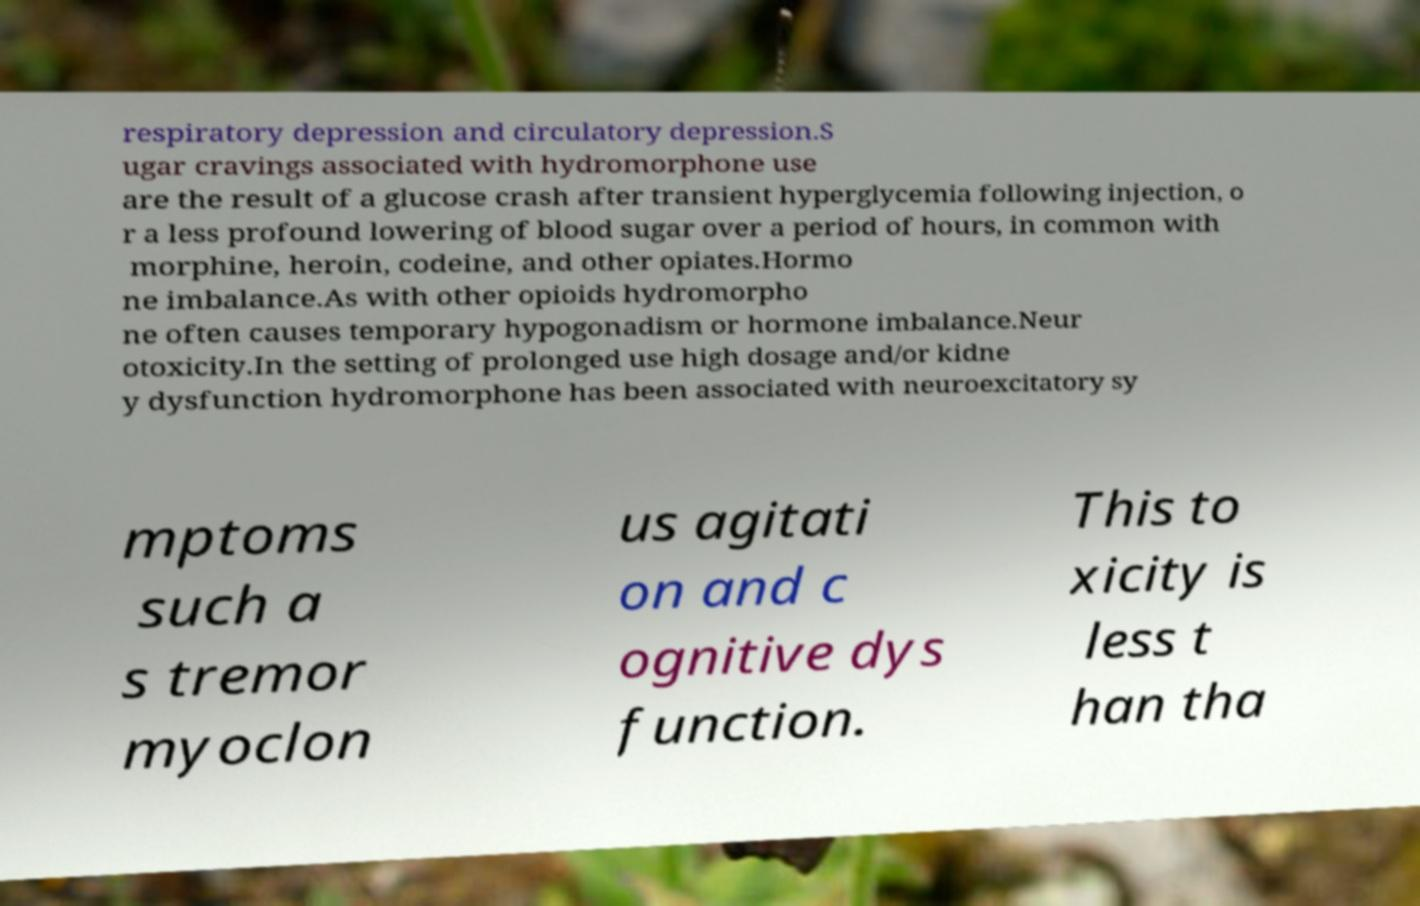Can you accurately transcribe the text from the provided image for me? respiratory depression and circulatory depression.S ugar cravings associated with hydromorphone use are the result of a glucose crash after transient hyperglycemia following injection, o r a less profound lowering of blood sugar over a period of hours, in common with morphine, heroin, codeine, and other opiates.Hormo ne imbalance.As with other opioids hydromorpho ne often causes temporary hypogonadism or hormone imbalance.Neur otoxicity.In the setting of prolonged use high dosage and/or kidne y dysfunction hydromorphone has been associated with neuroexcitatory sy mptoms such a s tremor myoclon us agitati on and c ognitive dys function. This to xicity is less t han tha 